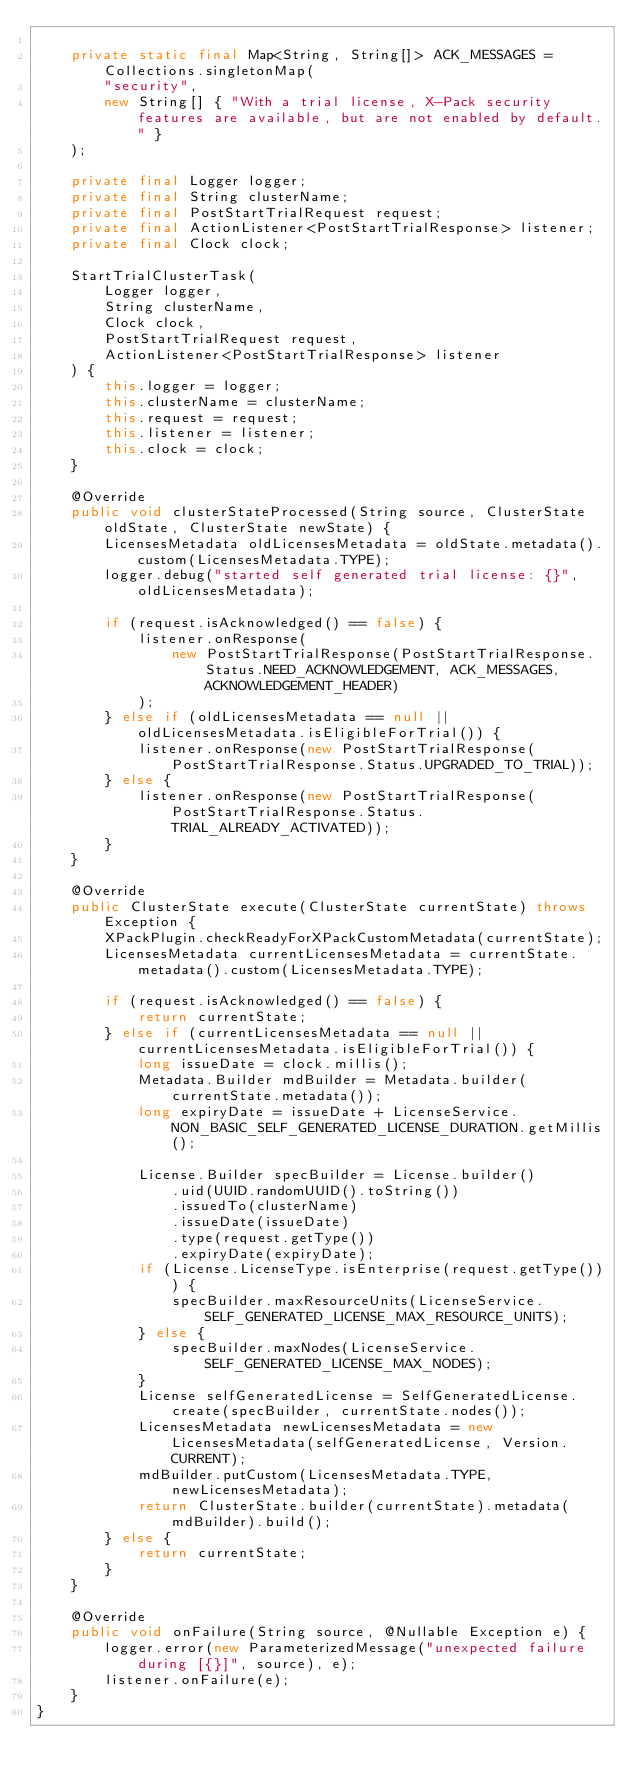<code> <loc_0><loc_0><loc_500><loc_500><_Java_>
    private static final Map<String, String[]> ACK_MESSAGES = Collections.singletonMap(
        "security",
        new String[] { "With a trial license, X-Pack security features are available, but are not enabled by default." }
    );

    private final Logger logger;
    private final String clusterName;
    private final PostStartTrialRequest request;
    private final ActionListener<PostStartTrialResponse> listener;
    private final Clock clock;

    StartTrialClusterTask(
        Logger logger,
        String clusterName,
        Clock clock,
        PostStartTrialRequest request,
        ActionListener<PostStartTrialResponse> listener
    ) {
        this.logger = logger;
        this.clusterName = clusterName;
        this.request = request;
        this.listener = listener;
        this.clock = clock;
    }

    @Override
    public void clusterStateProcessed(String source, ClusterState oldState, ClusterState newState) {
        LicensesMetadata oldLicensesMetadata = oldState.metadata().custom(LicensesMetadata.TYPE);
        logger.debug("started self generated trial license: {}", oldLicensesMetadata);

        if (request.isAcknowledged() == false) {
            listener.onResponse(
                new PostStartTrialResponse(PostStartTrialResponse.Status.NEED_ACKNOWLEDGEMENT, ACK_MESSAGES, ACKNOWLEDGEMENT_HEADER)
            );
        } else if (oldLicensesMetadata == null || oldLicensesMetadata.isEligibleForTrial()) {
            listener.onResponse(new PostStartTrialResponse(PostStartTrialResponse.Status.UPGRADED_TO_TRIAL));
        } else {
            listener.onResponse(new PostStartTrialResponse(PostStartTrialResponse.Status.TRIAL_ALREADY_ACTIVATED));
        }
    }

    @Override
    public ClusterState execute(ClusterState currentState) throws Exception {
        XPackPlugin.checkReadyForXPackCustomMetadata(currentState);
        LicensesMetadata currentLicensesMetadata = currentState.metadata().custom(LicensesMetadata.TYPE);

        if (request.isAcknowledged() == false) {
            return currentState;
        } else if (currentLicensesMetadata == null || currentLicensesMetadata.isEligibleForTrial()) {
            long issueDate = clock.millis();
            Metadata.Builder mdBuilder = Metadata.builder(currentState.metadata());
            long expiryDate = issueDate + LicenseService.NON_BASIC_SELF_GENERATED_LICENSE_DURATION.getMillis();

            License.Builder specBuilder = License.builder()
                .uid(UUID.randomUUID().toString())
                .issuedTo(clusterName)
                .issueDate(issueDate)
                .type(request.getType())
                .expiryDate(expiryDate);
            if (License.LicenseType.isEnterprise(request.getType())) {
                specBuilder.maxResourceUnits(LicenseService.SELF_GENERATED_LICENSE_MAX_RESOURCE_UNITS);
            } else {
                specBuilder.maxNodes(LicenseService.SELF_GENERATED_LICENSE_MAX_NODES);
            }
            License selfGeneratedLicense = SelfGeneratedLicense.create(specBuilder, currentState.nodes());
            LicensesMetadata newLicensesMetadata = new LicensesMetadata(selfGeneratedLicense, Version.CURRENT);
            mdBuilder.putCustom(LicensesMetadata.TYPE, newLicensesMetadata);
            return ClusterState.builder(currentState).metadata(mdBuilder).build();
        } else {
            return currentState;
        }
    }

    @Override
    public void onFailure(String source, @Nullable Exception e) {
        logger.error(new ParameterizedMessage("unexpected failure during [{}]", source), e);
        listener.onFailure(e);
    }
}
</code> 